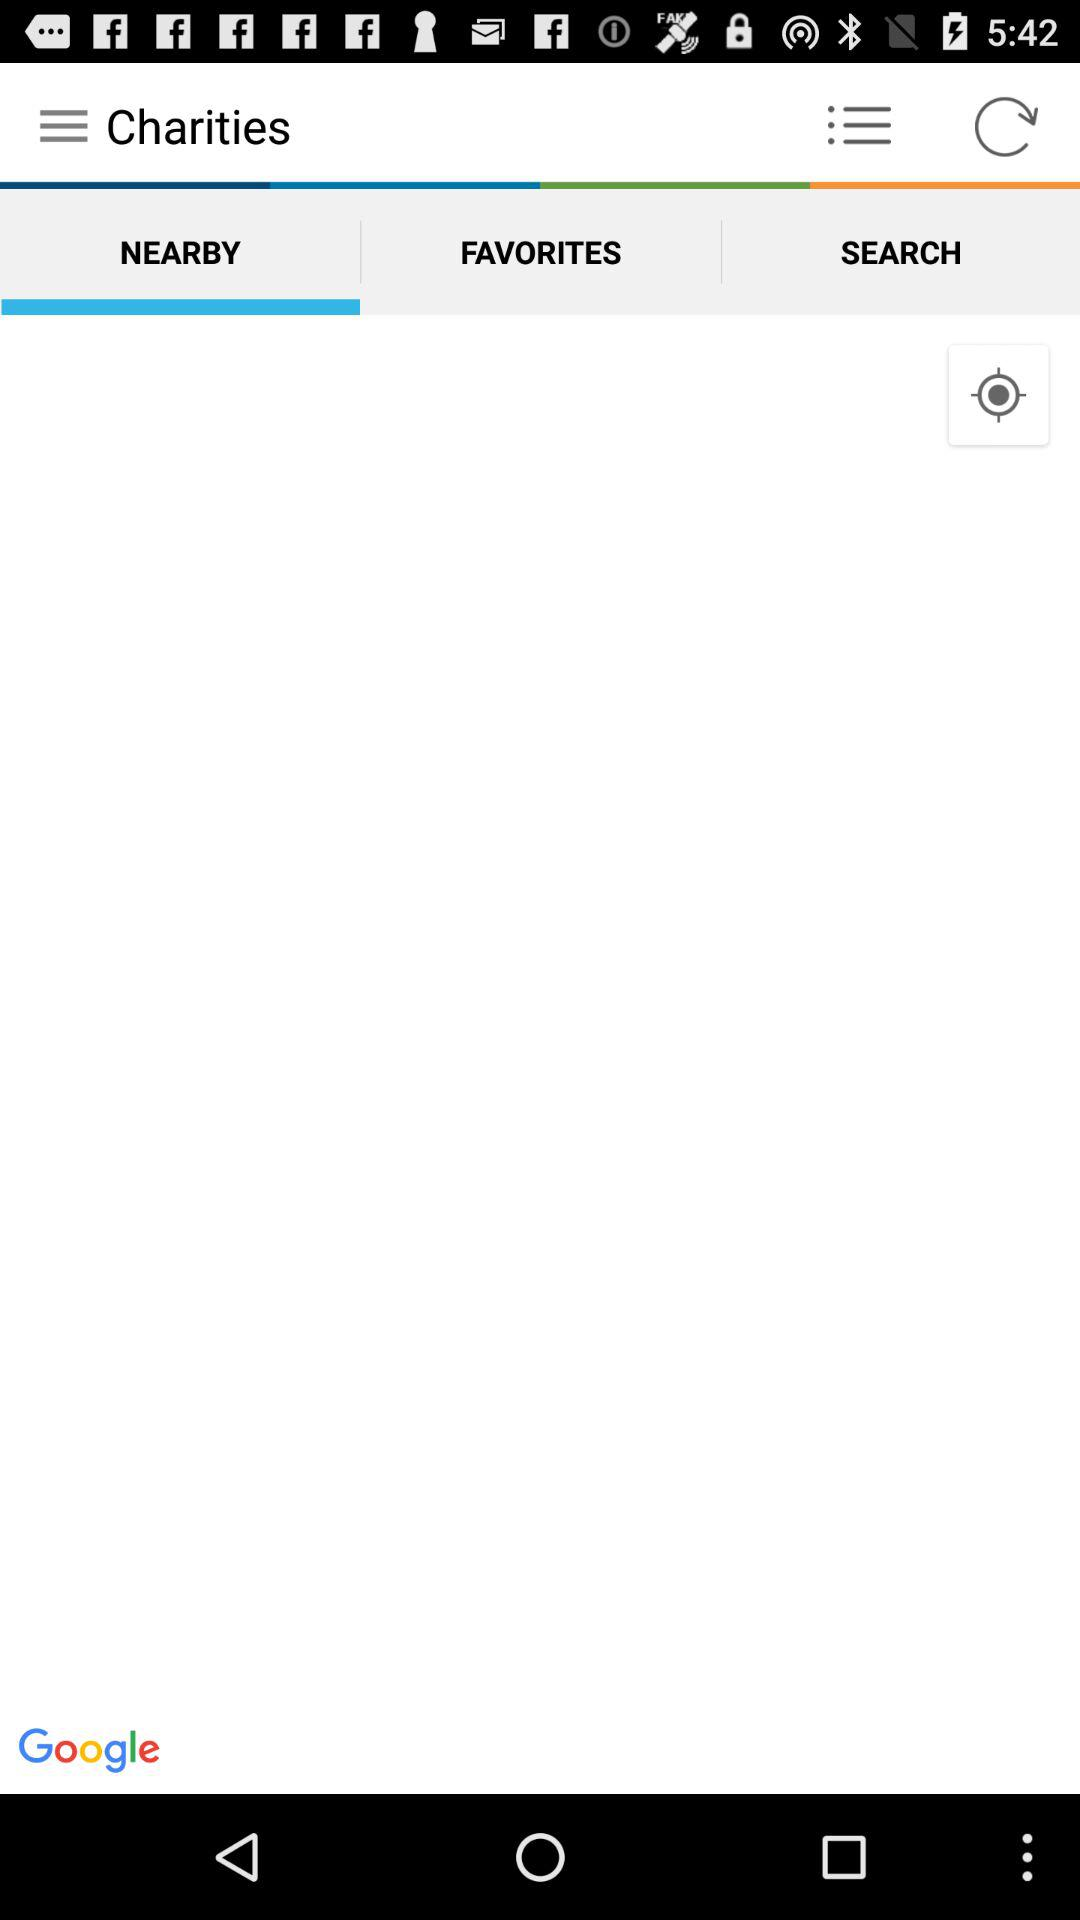Which tab is selected? The selected tab is "NEARBY". 